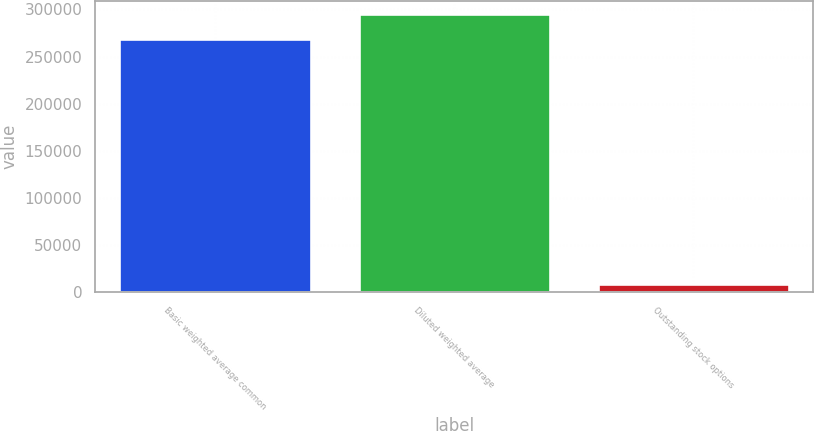Convert chart to OTSL. <chart><loc_0><loc_0><loc_500><loc_500><bar_chart><fcel>Basic weighted average common<fcel>Diluted weighted average<fcel>Outstanding stock options<nl><fcel>268704<fcel>294730<fcel>8445<nl></chart> 